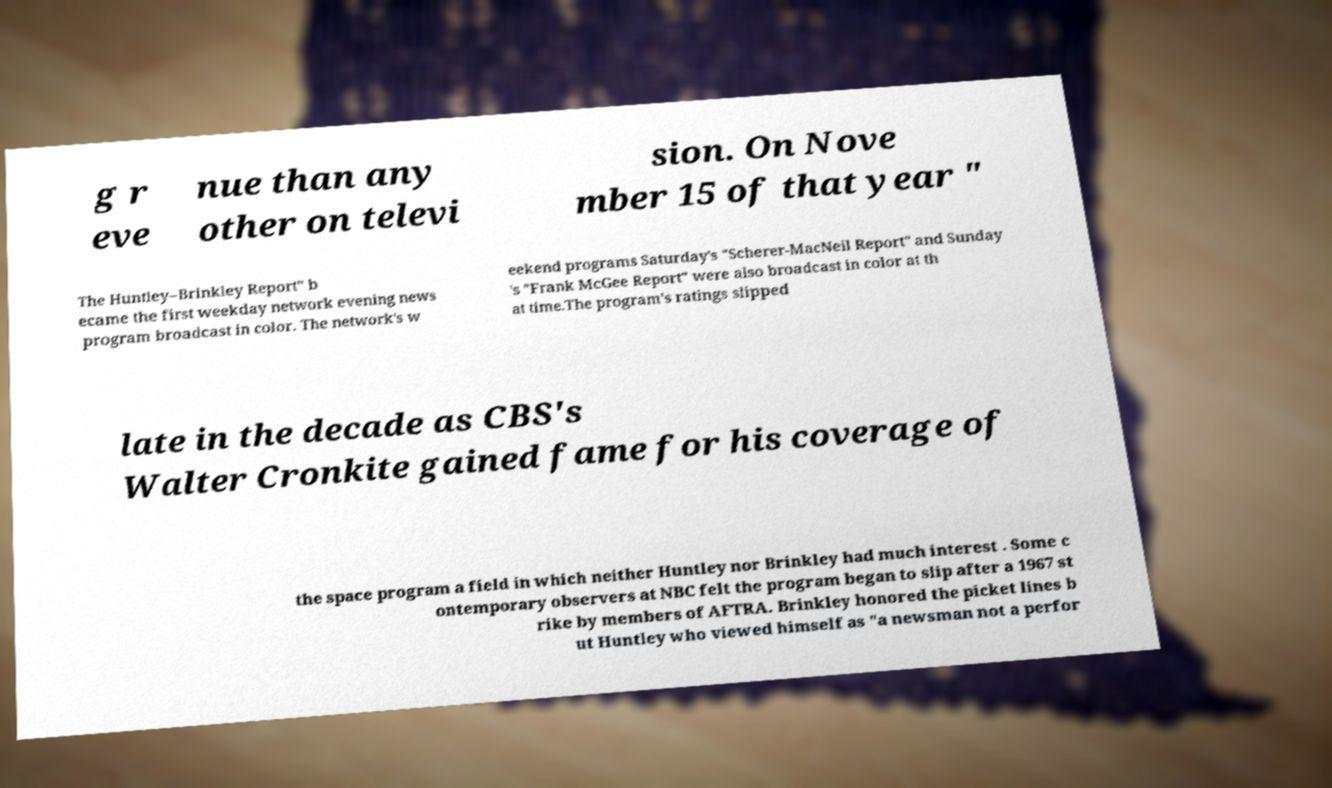I need the written content from this picture converted into text. Can you do that? g r eve nue than any other on televi sion. On Nove mber 15 of that year " The Huntley–Brinkley Report" b ecame the first weekday network evening news program broadcast in color. The network's w eekend programs Saturday's "Scherer-MacNeil Report" and Sunday 's "Frank McGee Report" were also broadcast in color at th at time.The program's ratings slipped late in the decade as CBS's Walter Cronkite gained fame for his coverage of the space program a field in which neither Huntley nor Brinkley had much interest . Some c ontemporary observers at NBC felt the program began to slip after a 1967 st rike by members of AFTRA. Brinkley honored the picket lines b ut Huntley who viewed himself as "a newsman not a perfor 